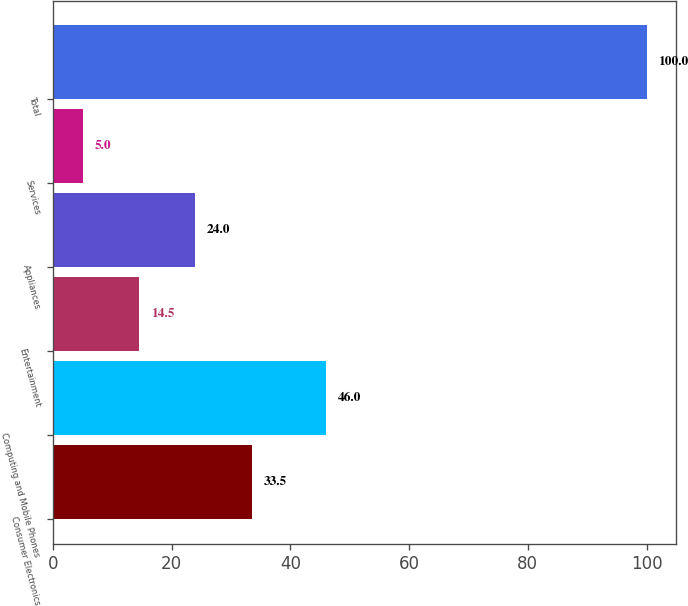Convert chart. <chart><loc_0><loc_0><loc_500><loc_500><bar_chart><fcel>Consumer Electronics<fcel>Computing and Mobile Phones<fcel>Entertainment<fcel>Appliances<fcel>Services<fcel>Total<nl><fcel>33.5<fcel>46<fcel>14.5<fcel>24<fcel>5<fcel>100<nl></chart> 